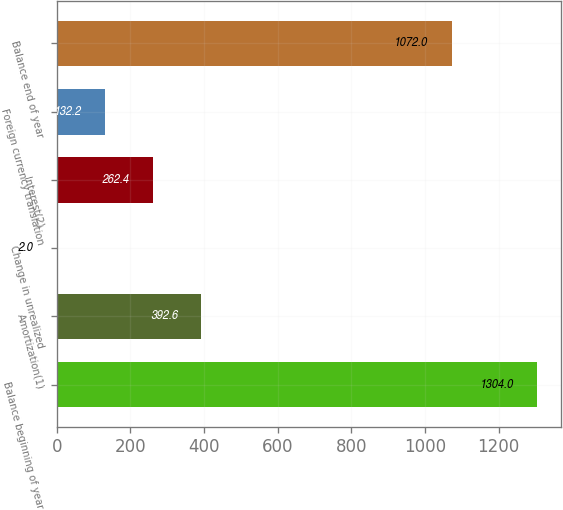<chart> <loc_0><loc_0><loc_500><loc_500><bar_chart><fcel>Balance beginning of year<fcel>Amortization(1)<fcel>Change in unrealized<fcel>Interest(2)<fcel>Foreign currency translation<fcel>Balance end of year<nl><fcel>1304<fcel>392.6<fcel>2<fcel>262.4<fcel>132.2<fcel>1072<nl></chart> 